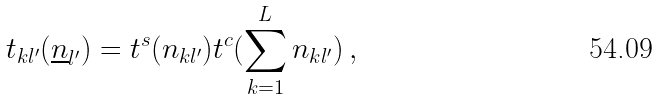<formula> <loc_0><loc_0><loc_500><loc_500>t _ { k l ^ { \prime } } ( \underline { n } _ { l ^ { \prime } } ) = t ^ { s } ( n _ { k l ^ { \prime } } ) t ^ { c } ( \sum _ { k = 1 } ^ { L } n _ { k l ^ { \prime } } ) \, ,</formula> 